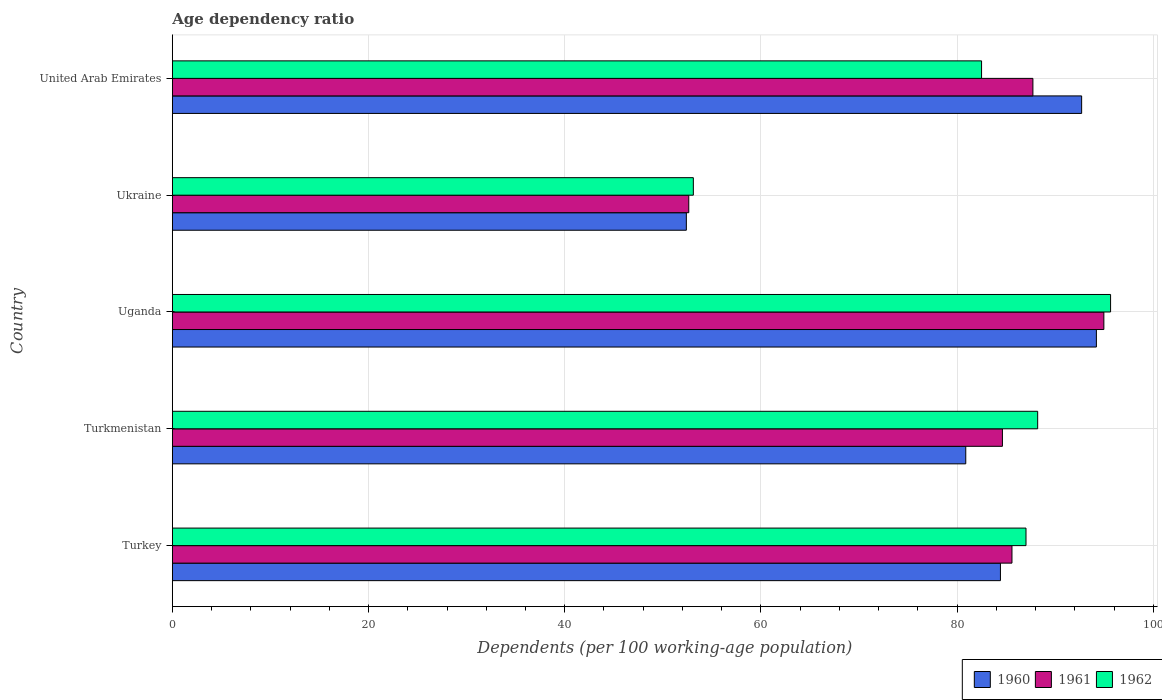How many groups of bars are there?
Provide a short and direct response. 5. Are the number of bars on each tick of the Y-axis equal?
Provide a succinct answer. Yes. How many bars are there on the 2nd tick from the top?
Provide a short and direct response. 3. How many bars are there on the 1st tick from the bottom?
Ensure brevity in your answer.  3. What is the label of the 5th group of bars from the top?
Ensure brevity in your answer.  Turkey. What is the age dependency ratio in in 1962 in Uganda?
Your answer should be very brief. 95.65. Across all countries, what is the maximum age dependency ratio in in 1961?
Make the answer very short. 94.97. Across all countries, what is the minimum age dependency ratio in in 1961?
Your response must be concise. 52.65. In which country was the age dependency ratio in in 1962 maximum?
Your answer should be very brief. Uganda. In which country was the age dependency ratio in in 1961 minimum?
Provide a succinct answer. Ukraine. What is the total age dependency ratio in in 1962 in the graph?
Give a very brief answer. 406.51. What is the difference between the age dependency ratio in in 1961 in Turkmenistan and that in United Arab Emirates?
Keep it short and to the point. -3.11. What is the difference between the age dependency ratio in in 1962 in Uganda and the age dependency ratio in in 1960 in Turkmenistan?
Offer a very short reply. 14.76. What is the average age dependency ratio in in 1961 per country?
Provide a short and direct response. 81.11. What is the difference between the age dependency ratio in in 1960 and age dependency ratio in in 1962 in United Arab Emirates?
Your answer should be very brief. 10.2. What is the ratio of the age dependency ratio in in 1961 in Turkey to that in Uganda?
Make the answer very short. 0.9. Is the age dependency ratio in in 1960 in Turkey less than that in Uganda?
Make the answer very short. Yes. Is the difference between the age dependency ratio in in 1960 in Uganda and Ukraine greater than the difference between the age dependency ratio in in 1962 in Uganda and Ukraine?
Your answer should be compact. No. What is the difference between the highest and the second highest age dependency ratio in in 1960?
Provide a succinct answer. 1.5. What is the difference between the highest and the lowest age dependency ratio in in 1961?
Your response must be concise. 42.32. Is the sum of the age dependency ratio in in 1960 in Turkey and Ukraine greater than the maximum age dependency ratio in in 1961 across all countries?
Your response must be concise. Yes. What does the 1st bar from the top in Uganda represents?
Your answer should be very brief. 1962. What does the 3rd bar from the bottom in Turkmenistan represents?
Keep it short and to the point. 1962. Is it the case that in every country, the sum of the age dependency ratio in in 1962 and age dependency ratio in in 1960 is greater than the age dependency ratio in in 1961?
Your response must be concise. Yes. How many bars are there?
Your response must be concise. 15. What is the difference between two consecutive major ticks on the X-axis?
Your answer should be compact. 20. Are the values on the major ticks of X-axis written in scientific E-notation?
Your answer should be very brief. No. How are the legend labels stacked?
Your answer should be compact. Horizontal. What is the title of the graph?
Make the answer very short. Age dependency ratio. Does "1983" appear as one of the legend labels in the graph?
Provide a short and direct response. No. What is the label or title of the X-axis?
Make the answer very short. Dependents (per 100 working-age population). What is the Dependents (per 100 working-age population) of 1960 in Turkey?
Your answer should be compact. 84.42. What is the Dependents (per 100 working-age population) of 1961 in Turkey?
Offer a terse response. 85.6. What is the Dependents (per 100 working-age population) of 1962 in Turkey?
Offer a very short reply. 87.03. What is the Dependents (per 100 working-age population) of 1960 in Turkmenistan?
Ensure brevity in your answer.  80.89. What is the Dependents (per 100 working-age population) of 1961 in Turkmenistan?
Provide a succinct answer. 84.62. What is the Dependents (per 100 working-age population) in 1962 in Turkmenistan?
Your answer should be compact. 88.22. What is the Dependents (per 100 working-age population) in 1960 in Uganda?
Give a very brief answer. 94.21. What is the Dependents (per 100 working-age population) in 1961 in Uganda?
Your answer should be very brief. 94.97. What is the Dependents (per 100 working-age population) of 1962 in Uganda?
Your response must be concise. 95.65. What is the Dependents (per 100 working-age population) of 1960 in Ukraine?
Ensure brevity in your answer.  52.4. What is the Dependents (per 100 working-age population) of 1961 in Ukraine?
Your answer should be very brief. 52.65. What is the Dependents (per 100 working-age population) in 1962 in Ukraine?
Ensure brevity in your answer.  53.12. What is the Dependents (per 100 working-age population) of 1960 in United Arab Emirates?
Keep it short and to the point. 92.7. What is the Dependents (per 100 working-age population) of 1961 in United Arab Emirates?
Provide a succinct answer. 87.73. What is the Dependents (per 100 working-age population) in 1962 in United Arab Emirates?
Ensure brevity in your answer.  82.5. Across all countries, what is the maximum Dependents (per 100 working-age population) of 1960?
Your response must be concise. 94.21. Across all countries, what is the maximum Dependents (per 100 working-age population) of 1961?
Your response must be concise. 94.97. Across all countries, what is the maximum Dependents (per 100 working-age population) of 1962?
Offer a very short reply. 95.65. Across all countries, what is the minimum Dependents (per 100 working-age population) of 1960?
Provide a succinct answer. 52.4. Across all countries, what is the minimum Dependents (per 100 working-age population) of 1961?
Your answer should be very brief. 52.65. Across all countries, what is the minimum Dependents (per 100 working-age population) of 1962?
Ensure brevity in your answer.  53.12. What is the total Dependents (per 100 working-age population) in 1960 in the graph?
Ensure brevity in your answer.  404.62. What is the total Dependents (per 100 working-age population) of 1961 in the graph?
Make the answer very short. 405.57. What is the total Dependents (per 100 working-age population) of 1962 in the graph?
Keep it short and to the point. 406.51. What is the difference between the Dependents (per 100 working-age population) in 1960 in Turkey and that in Turkmenistan?
Provide a succinct answer. 3.54. What is the difference between the Dependents (per 100 working-age population) of 1961 in Turkey and that in Turkmenistan?
Provide a short and direct response. 0.97. What is the difference between the Dependents (per 100 working-age population) in 1962 in Turkey and that in Turkmenistan?
Keep it short and to the point. -1.19. What is the difference between the Dependents (per 100 working-age population) in 1960 in Turkey and that in Uganda?
Offer a terse response. -9.78. What is the difference between the Dependents (per 100 working-age population) of 1961 in Turkey and that in Uganda?
Offer a terse response. -9.37. What is the difference between the Dependents (per 100 working-age population) in 1962 in Turkey and that in Uganda?
Your answer should be compact. -8.62. What is the difference between the Dependents (per 100 working-age population) in 1960 in Turkey and that in Ukraine?
Your answer should be very brief. 32.02. What is the difference between the Dependents (per 100 working-age population) in 1961 in Turkey and that in Ukraine?
Keep it short and to the point. 32.95. What is the difference between the Dependents (per 100 working-age population) of 1962 in Turkey and that in Ukraine?
Ensure brevity in your answer.  33.91. What is the difference between the Dependents (per 100 working-age population) in 1960 in Turkey and that in United Arab Emirates?
Offer a very short reply. -8.28. What is the difference between the Dependents (per 100 working-age population) of 1961 in Turkey and that in United Arab Emirates?
Keep it short and to the point. -2.13. What is the difference between the Dependents (per 100 working-age population) in 1962 in Turkey and that in United Arab Emirates?
Your response must be concise. 4.53. What is the difference between the Dependents (per 100 working-age population) of 1960 in Turkmenistan and that in Uganda?
Offer a terse response. -13.32. What is the difference between the Dependents (per 100 working-age population) in 1961 in Turkmenistan and that in Uganda?
Your response must be concise. -10.34. What is the difference between the Dependents (per 100 working-age population) in 1962 in Turkmenistan and that in Uganda?
Make the answer very short. -7.43. What is the difference between the Dependents (per 100 working-age population) in 1960 in Turkmenistan and that in Ukraine?
Give a very brief answer. 28.49. What is the difference between the Dependents (per 100 working-age population) of 1961 in Turkmenistan and that in Ukraine?
Your response must be concise. 31.98. What is the difference between the Dependents (per 100 working-age population) of 1962 in Turkmenistan and that in Ukraine?
Provide a succinct answer. 35.1. What is the difference between the Dependents (per 100 working-age population) of 1960 in Turkmenistan and that in United Arab Emirates?
Your answer should be compact. -11.81. What is the difference between the Dependents (per 100 working-age population) in 1961 in Turkmenistan and that in United Arab Emirates?
Your answer should be very brief. -3.11. What is the difference between the Dependents (per 100 working-age population) of 1962 in Turkmenistan and that in United Arab Emirates?
Provide a short and direct response. 5.72. What is the difference between the Dependents (per 100 working-age population) in 1960 in Uganda and that in Ukraine?
Your response must be concise. 41.8. What is the difference between the Dependents (per 100 working-age population) in 1961 in Uganda and that in Ukraine?
Give a very brief answer. 42.32. What is the difference between the Dependents (per 100 working-age population) in 1962 in Uganda and that in Ukraine?
Make the answer very short. 42.54. What is the difference between the Dependents (per 100 working-age population) of 1960 in Uganda and that in United Arab Emirates?
Make the answer very short. 1.5. What is the difference between the Dependents (per 100 working-age population) of 1961 in Uganda and that in United Arab Emirates?
Your answer should be compact. 7.23. What is the difference between the Dependents (per 100 working-age population) of 1962 in Uganda and that in United Arab Emirates?
Your answer should be very brief. 13.15. What is the difference between the Dependents (per 100 working-age population) of 1960 in Ukraine and that in United Arab Emirates?
Make the answer very short. -40.3. What is the difference between the Dependents (per 100 working-age population) of 1961 in Ukraine and that in United Arab Emirates?
Offer a very short reply. -35.09. What is the difference between the Dependents (per 100 working-age population) of 1962 in Ukraine and that in United Arab Emirates?
Keep it short and to the point. -29.38. What is the difference between the Dependents (per 100 working-age population) in 1960 in Turkey and the Dependents (per 100 working-age population) in 1961 in Turkmenistan?
Provide a succinct answer. -0.2. What is the difference between the Dependents (per 100 working-age population) in 1960 in Turkey and the Dependents (per 100 working-age population) in 1962 in Turkmenistan?
Provide a succinct answer. -3.8. What is the difference between the Dependents (per 100 working-age population) in 1961 in Turkey and the Dependents (per 100 working-age population) in 1962 in Turkmenistan?
Your response must be concise. -2.62. What is the difference between the Dependents (per 100 working-age population) of 1960 in Turkey and the Dependents (per 100 working-age population) of 1961 in Uganda?
Make the answer very short. -10.54. What is the difference between the Dependents (per 100 working-age population) of 1960 in Turkey and the Dependents (per 100 working-age population) of 1962 in Uganda?
Your response must be concise. -11.23. What is the difference between the Dependents (per 100 working-age population) in 1961 in Turkey and the Dependents (per 100 working-age population) in 1962 in Uganda?
Make the answer very short. -10.05. What is the difference between the Dependents (per 100 working-age population) in 1960 in Turkey and the Dependents (per 100 working-age population) in 1961 in Ukraine?
Your answer should be very brief. 31.78. What is the difference between the Dependents (per 100 working-age population) of 1960 in Turkey and the Dependents (per 100 working-age population) of 1962 in Ukraine?
Your response must be concise. 31.31. What is the difference between the Dependents (per 100 working-age population) in 1961 in Turkey and the Dependents (per 100 working-age population) in 1962 in Ukraine?
Make the answer very short. 32.48. What is the difference between the Dependents (per 100 working-age population) of 1960 in Turkey and the Dependents (per 100 working-age population) of 1961 in United Arab Emirates?
Your answer should be very brief. -3.31. What is the difference between the Dependents (per 100 working-age population) of 1960 in Turkey and the Dependents (per 100 working-age population) of 1962 in United Arab Emirates?
Your answer should be compact. 1.93. What is the difference between the Dependents (per 100 working-age population) of 1961 in Turkey and the Dependents (per 100 working-age population) of 1962 in United Arab Emirates?
Offer a very short reply. 3.1. What is the difference between the Dependents (per 100 working-age population) of 1960 in Turkmenistan and the Dependents (per 100 working-age population) of 1961 in Uganda?
Make the answer very short. -14.08. What is the difference between the Dependents (per 100 working-age population) in 1960 in Turkmenistan and the Dependents (per 100 working-age population) in 1962 in Uganda?
Make the answer very short. -14.76. What is the difference between the Dependents (per 100 working-age population) of 1961 in Turkmenistan and the Dependents (per 100 working-age population) of 1962 in Uganda?
Ensure brevity in your answer.  -11.03. What is the difference between the Dependents (per 100 working-age population) in 1960 in Turkmenistan and the Dependents (per 100 working-age population) in 1961 in Ukraine?
Your answer should be compact. 28.24. What is the difference between the Dependents (per 100 working-age population) in 1960 in Turkmenistan and the Dependents (per 100 working-age population) in 1962 in Ukraine?
Offer a terse response. 27.77. What is the difference between the Dependents (per 100 working-age population) in 1961 in Turkmenistan and the Dependents (per 100 working-age population) in 1962 in Ukraine?
Make the answer very short. 31.51. What is the difference between the Dependents (per 100 working-age population) in 1960 in Turkmenistan and the Dependents (per 100 working-age population) in 1961 in United Arab Emirates?
Offer a terse response. -6.84. What is the difference between the Dependents (per 100 working-age population) in 1960 in Turkmenistan and the Dependents (per 100 working-age population) in 1962 in United Arab Emirates?
Your answer should be very brief. -1.61. What is the difference between the Dependents (per 100 working-age population) in 1961 in Turkmenistan and the Dependents (per 100 working-age population) in 1962 in United Arab Emirates?
Offer a very short reply. 2.13. What is the difference between the Dependents (per 100 working-age population) of 1960 in Uganda and the Dependents (per 100 working-age population) of 1961 in Ukraine?
Your answer should be very brief. 41.56. What is the difference between the Dependents (per 100 working-age population) in 1960 in Uganda and the Dependents (per 100 working-age population) in 1962 in Ukraine?
Offer a terse response. 41.09. What is the difference between the Dependents (per 100 working-age population) in 1961 in Uganda and the Dependents (per 100 working-age population) in 1962 in Ukraine?
Keep it short and to the point. 41.85. What is the difference between the Dependents (per 100 working-age population) in 1960 in Uganda and the Dependents (per 100 working-age population) in 1961 in United Arab Emirates?
Offer a very short reply. 6.47. What is the difference between the Dependents (per 100 working-age population) in 1960 in Uganda and the Dependents (per 100 working-age population) in 1962 in United Arab Emirates?
Provide a short and direct response. 11.71. What is the difference between the Dependents (per 100 working-age population) in 1961 in Uganda and the Dependents (per 100 working-age population) in 1962 in United Arab Emirates?
Offer a very short reply. 12.47. What is the difference between the Dependents (per 100 working-age population) in 1960 in Ukraine and the Dependents (per 100 working-age population) in 1961 in United Arab Emirates?
Your response must be concise. -35.33. What is the difference between the Dependents (per 100 working-age population) of 1960 in Ukraine and the Dependents (per 100 working-age population) of 1962 in United Arab Emirates?
Provide a succinct answer. -30.1. What is the difference between the Dependents (per 100 working-age population) in 1961 in Ukraine and the Dependents (per 100 working-age population) in 1962 in United Arab Emirates?
Give a very brief answer. -29.85. What is the average Dependents (per 100 working-age population) in 1960 per country?
Your response must be concise. 80.92. What is the average Dependents (per 100 working-age population) of 1961 per country?
Keep it short and to the point. 81.11. What is the average Dependents (per 100 working-age population) in 1962 per country?
Your answer should be compact. 81.3. What is the difference between the Dependents (per 100 working-age population) in 1960 and Dependents (per 100 working-age population) in 1961 in Turkey?
Keep it short and to the point. -1.17. What is the difference between the Dependents (per 100 working-age population) in 1960 and Dependents (per 100 working-age population) in 1962 in Turkey?
Keep it short and to the point. -2.61. What is the difference between the Dependents (per 100 working-age population) of 1961 and Dependents (per 100 working-age population) of 1962 in Turkey?
Your answer should be very brief. -1.43. What is the difference between the Dependents (per 100 working-age population) of 1960 and Dependents (per 100 working-age population) of 1961 in Turkmenistan?
Provide a short and direct response. -3.74. What is the difference between the Dependents (per 100 working-age population) in 1960 and Dependents (per 100 working-age population) in 1962 in Turkmenistan?
Provide a succinct answer. -7.33. What is the difference between the Dependents (per 100 working-age population) of 1961 and Dependents (per 100 working-age population) of 1962 in Turkmenistan?
Give a very brief answer. -3.59. What is the difference between the Dependents (per 100 working-age population) of 1960 and Dependents (per 100 working-age population) of 1961 in Uganda?
Provide a short and direct response. -0.76. What is the difference between the Dependents (per 100 working-age population) of 1960 and Dependents (per 100 working-age population) of 1962 in Uganda?
Make the answer very short. -1.45. What is the difference between the Dependents (per 100 working-age population) of 1961 and Dependents (per 100 working-age population) of 1962 in Uganda?
Provide a succinct answer. -0.68. What is the difference between the Dependents (per 100 working-age population) of 1960 and Dependents (per 100 working-age population) of 1961 in Ukraine?
Provide a short and direct response. -0.25. What is the difference between the Dependents (per 100 working-age population) of 1960 and Dependents (per 100 working-age population) of 1962 in Ukraine?
Make the answer very short. -0.71. What is the difference between the Dependents (per 100 working-age population) in 1961 and Dependents (per 100 working-age population) in 1962 in Ukraine?
Offer a terse response. -0.47. What is the difference between the Dependents (per 100 working-age population) in 1960 and Dependents (per 100 working-age population) in 1961 in United Arab Emirates?
Give a very brief answer. 4.97. What is the difference between the Dependents (per 100 working-age population) of 1960 and Dependents (per 100 working-age population) of 1962 in United Arab Emirates?
Give a very brief answer. 10.2. What is the difference between the Dependents (per 100 working-age population) of 1961 and Dependents (per 100 working-age population) of 1962 in United Arab Emirates?
Your answer should be compact. 5.23. What is the ratio of the Dependents (per 100 working-age population) in 1960 in Turkey to that in Turkmenistan?
Your response must be concise. 1.04. What is the ratio of the Dependents (per 100 working-age population) of 1961 in Turkey to that in Turkmenistan?
Provide a succinct answer. 1.01. What is the ratio of the Dependents (per 100 working-age population) of 1962 in Turkey to that in Turkmenistan?
Keep it short and to the point. 0.99. What is the ratio of the Dependents (per 100 working-age population) in 1960 in Turkey to that in Uganda?
Give a very brief answer. 0.9. What is the ratio of the Dependents (per 100 working-age population) of 1961 in Turkey to that in Uganda?
Provide a succinct answer. 0.9. What is the ratio of the Dependents (per 100 working-age population) of 1962 in Turkey to that in Uganda?
Make the answer very short. 0.91. What is the ratio of the Dependents (per 100 working-age population) in 1960 in Turkey to that in Ukraine?
Provide a succinct answer. 1.61. What is the ratio of the Dependents (per 100 working-age population) of 1961 in Turkey to that in Ukraine?
Ensure brevity in your answer.  1.63. What is the ratio of the Dependents (per 100 working-age population) of 1962 in Turkey to that in Ukraine?
Keep it short and to the point. 1.64. What is the ratio of the Dependents (per 100 working-age population) of 1960 in Turkey to that in United Arab Emirates?
Offer a terse response. 0.91. What is the ratio of the Dependents (per 100 working-age population) of 1961 in Turkey to that in United Arab Emirates?
Provide a short and direct response. 0.98. What is the ratio of the Dependents (per 100 working-age population) of 1962 in Turkey to that in United Arab Emirates?
Make the answer very short. 1.05. What is the ratio of the Dependents (per 100 working-age population) in 1960 in Turkmenistan to that in Uganda?
Give a very brief answer. 0.86. What is the ratio of the Dependents (per 100 working-age population) in 1961 in Turkmenistan to that in Uganda?
Provide a short and direct response. 0.89. What is the ratio of the Dependents (per 100 working-age population) of 1962 in Turkmenistan to that in Uganda?
Keep it short and to the point. 0.92. What is the ratio of the Dependents (per 100 working-age population) in 1960 in Turkmenistan to that in Ukraine?
Your answer should be compact. 1.54. What is the ratio of the Dependents (per 100 working-age population) of 1961 in Turkmenistan to that in Ukraine?
Keep it short and to the point. 1.61. What is the ratio of the Dependents (per 100 working-age population) in 1962 in Turkmenistan to that in Ukraine?
Give a very brief answer. 1.66. What is the ratio of the Dependents (per 100 working-age population) of 1960 in Turkmenistan to that in United Arab Emirates?
Your response must be concise. 0.87. What is the ratio of the Dependents (per 100 working-age population) in 1961 in Turkmenistan to that in United Arab Emirates?
Your answer should be very brief. 0.96. What is the ratio of the Dependents (per 100 working-age population) of 1962 in Turkmenistan to that in United Arab Emirates?
Provide a short and direct response. 1.07. What is the ratio of the Dependents (per 100 working-age population) in 1960 in Uganda to that in Ukraine?
Your answer should be compact. 1.8. What is the ratio of the Dependents (per 100 working-age population) in 1961 in Uganda to that in Ukraine?
Your answer should be compact. 1.8. What is the ratio of the Dependents (per 100 working-age population) in 1962 in Uganda to that in Ukraine?
Ensure brevity in your answer.  1.8. What is the ratio of the Dependents (per 100 working-age population) in 1960 in Uganda to that in United Arab Emirates?
Your response must be concise. 1.02. What is the ratio of the Dependents (per 100 working-age population) of 1961 in Uganda to that in United Arab Emirates?
Provide a succinct answer. 1.08. What is the ratio of the Dependents (per 100 working-age population) of 1962 in Uganda to that in United Arab Emirates?
Keep it short and to the point. 1.16. What is the ratio of the Dependents (per 100 working-age population) of 1960 in Ukraine to that in United Arab Emirates?
Your response must be concise. 0.57. What is the ratio of the Dependents (per 100 working-age population) of 1961 in Ukraine to that in United Arab Emirates?
Give a very brief answer. 0.6. What is the ratio of the Dependents (per 100 working-age population) of 1962 in Ukraine to that in United Arab Emirates?
Make the answer very short. 0.64. What is the difference between the highest and the second highest Dependents (per 100 working-age population) in 1960?
Provide a short and direct response. 1.5. What is the difference between the highest and the second highest Dependents (per 100 working-age population) of 1961?
Keep it short and to the point. 7.23. What is the difference between the highest and the second highest Dependents (per 100 working-age population) of 1962?
Offer a terse response. 7.43. What is the difference between the highest and the lowest Dependents (per 100 working-age population) in 1960?
Your response must be concise. 41.8. What is the difference between the highest and the lowest Dependents (per 100 working-age population) of 1961?
Your answer should be very brief. 42.32. What is the difference between the highest and the lowest Dependents (per 100 working-age population) in 1962?
Keep it short and to the point. 42.54. 